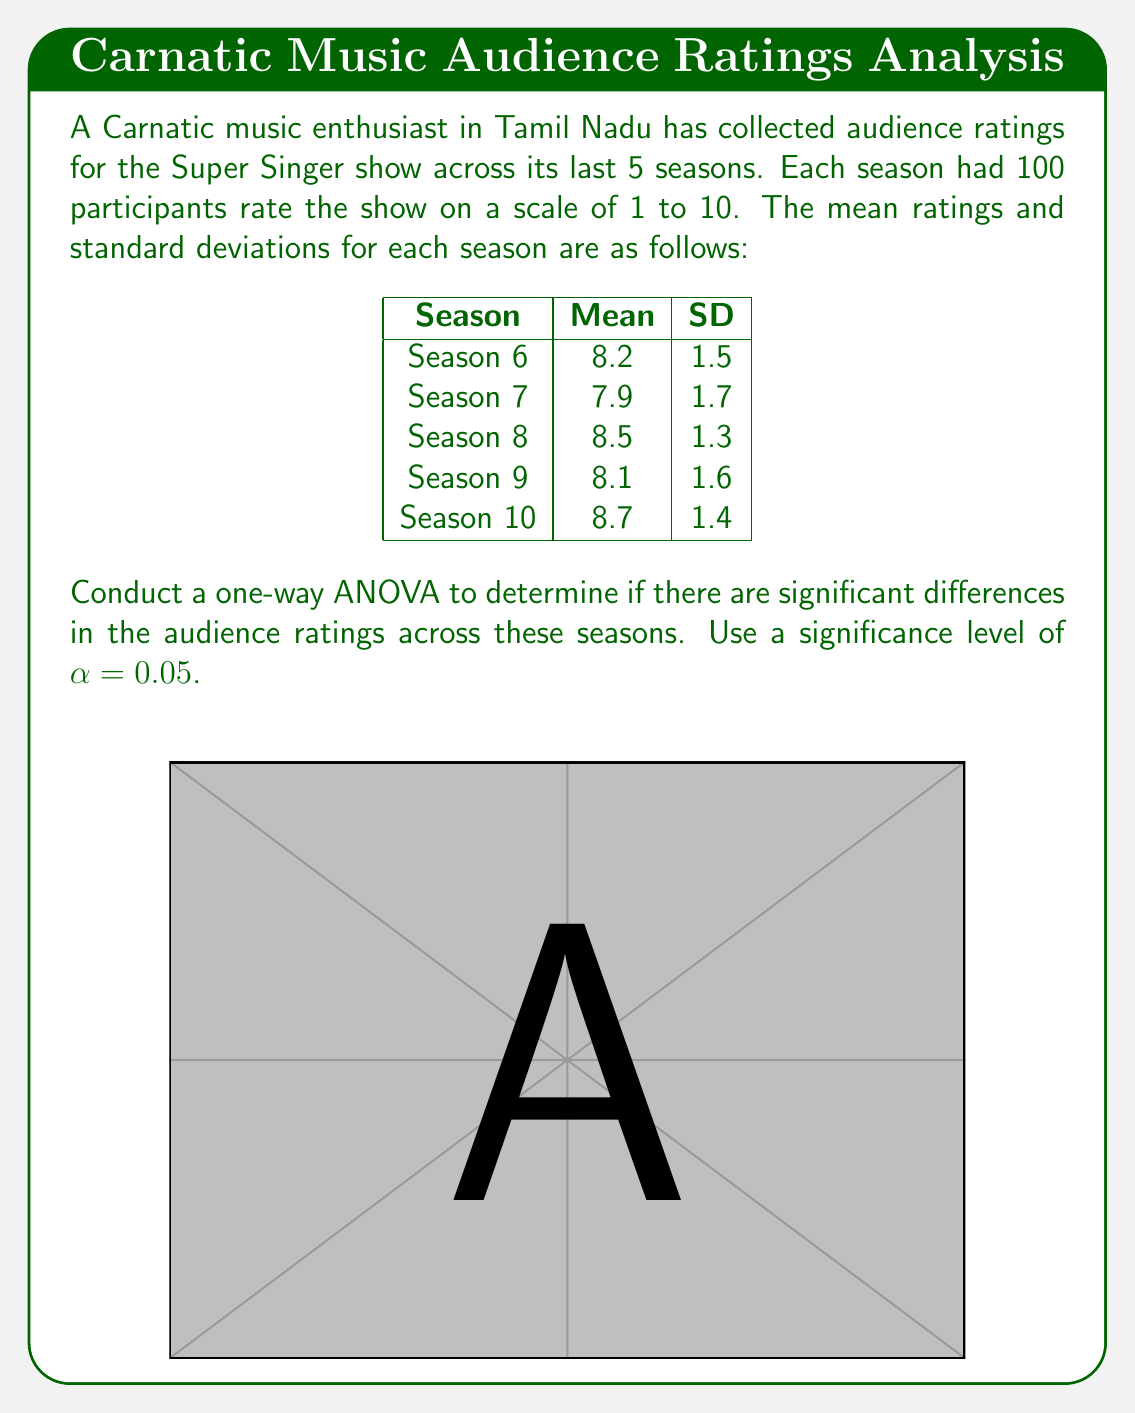Show me your answer to this math problem. To conduct a one-way ANOVA, we need to follow these steps:

1) Calculate the sum of squares between groups (SSB):
   $$SSB = n\sum_{i=1}^k (\bar{X_i} - \bar{X})^2$$
   where n is the number of participants per group, k is the number of groups, $\bar{X_i}$ is the mean of each group, and $\bar{X}$ is the grand mean.

2) Calculate the sum of squares within groups (SSW):
   $$SSW = \sum_{i=1}^k (n_i - 1)s_i^2$$
   where $n_i$ is the number of participants in each group and $s_i^2$ is the variance of each group.

3) Calculate the degrees of freedom:
   $$df_{between} = k - 1$$
   $$df_{within} = N - k$$
   where N is the total number of participants.

4) Calculate the mean squares:
   $$MSB = \frac{SSB}{df_{between}}$$
   $$MSW = \frac{SSW}{df_{within}}$$

5) Calculate the F-statistic:
   $$F = \frac{MSB}{MSW}$$

6) Compare the F-statistic to the critical F-value.

Let's perform these calculations:

1) Grand mean: $\bar{X} = \frac{8.2 + 7.9 + 8.5 + 8.1 + 8.7}{5} = 8.28$

   $$SSB = 100[(8.2 - 8.28)^2 + (7.9 - 8.28)^2 + (8.5 - 8.28)^2 + (8.1 - 8.28)^2 + (8.7 - 8.28)^2]$$
   $$SSB = 100[0.0064 + 0.1444 + 0.0484 + 0.0324 + 0.1764] = 40.8$$

2) $$SSW = 99(1.5^2 + 1.7^2 + 1.3^2 + 1.6^2 + 1.4^2) = 1188.54$$

3) $$df_{between} = 5 - 1 = 4$$
   $$df_{within} = 500 - 5 = 495$$

4) $$MSB = \frac{40.8}{4} = 10.2$$
   $$MSW = \frac{1188.54}{495} = 2.4011$$

5) $$F = \frac{10.2}{2.4011} = 4.2481$$

6) The critical F-value for α = 0.05, df_between = 4, and df_within = 495 is approximately 2.37.

Since our calculated F-value (4.2481) is greater than the critical F-value (2.37), we reject the null hypothesis.
Answer: F(4, 495) = 4.2481, p < 0.05. There are significant differences in audience ratings across seasons. 